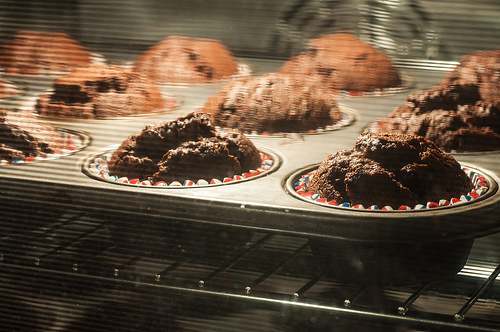<image>
Can you confirm if the cake is above the pan? No. The cake is not positioned above the pan. The vertical arrangement shows a different relationship. 